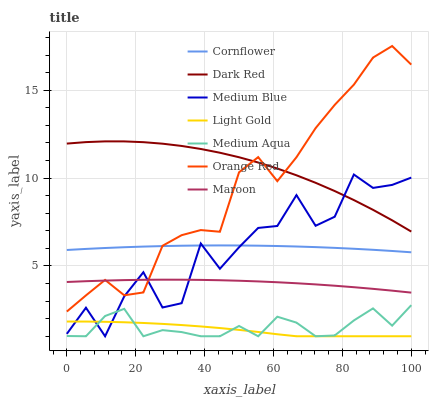Does Light Gold have the minimum area under the curve?
Answer yes or no. Yes. Does Dark Red have the maximum area under the curve?
Answer yes or no. Yes. Does Medium Blue have the minimum area under the curve?
Answer yes or no. No. Does Medium Blue have the maximum area under the curve?
Answer yes or no. No. Is Cornflower the smoothest?
Answer yes or no. Yes. Is Medium Blue the roughest?
Answer yes or no. Yes. Is Dark Red the smoothest?
Answer yes or no. No. Is Dark Red the roughest?
Answer yes or no. No. Does Medium Blue have the lowest value?
Answer yes or no. Yes. Does Dark Red have the lowest value?
Answer yes or no. No. Does Orange Red have the highest value?
Answer yes or no. Yes. Does Dark Red have the highest value?
Answer yes or no. No. Is Medium Aqua less than Orange Red?
Answer yes or no. Yes. Is Maroon greater than Light Gold?
Answer yes or no. Yes. Does Cornflower intersect Medium Blue?
Answer yes or no. Yes. Is Cornflower less than Medium Blue?
Answer yes or no. No. Is Cornflower greater than Medium Blue?
Answer yes or no. No. Does Medium Aqua intersect Orange Red?
Answer yes or no. No. 